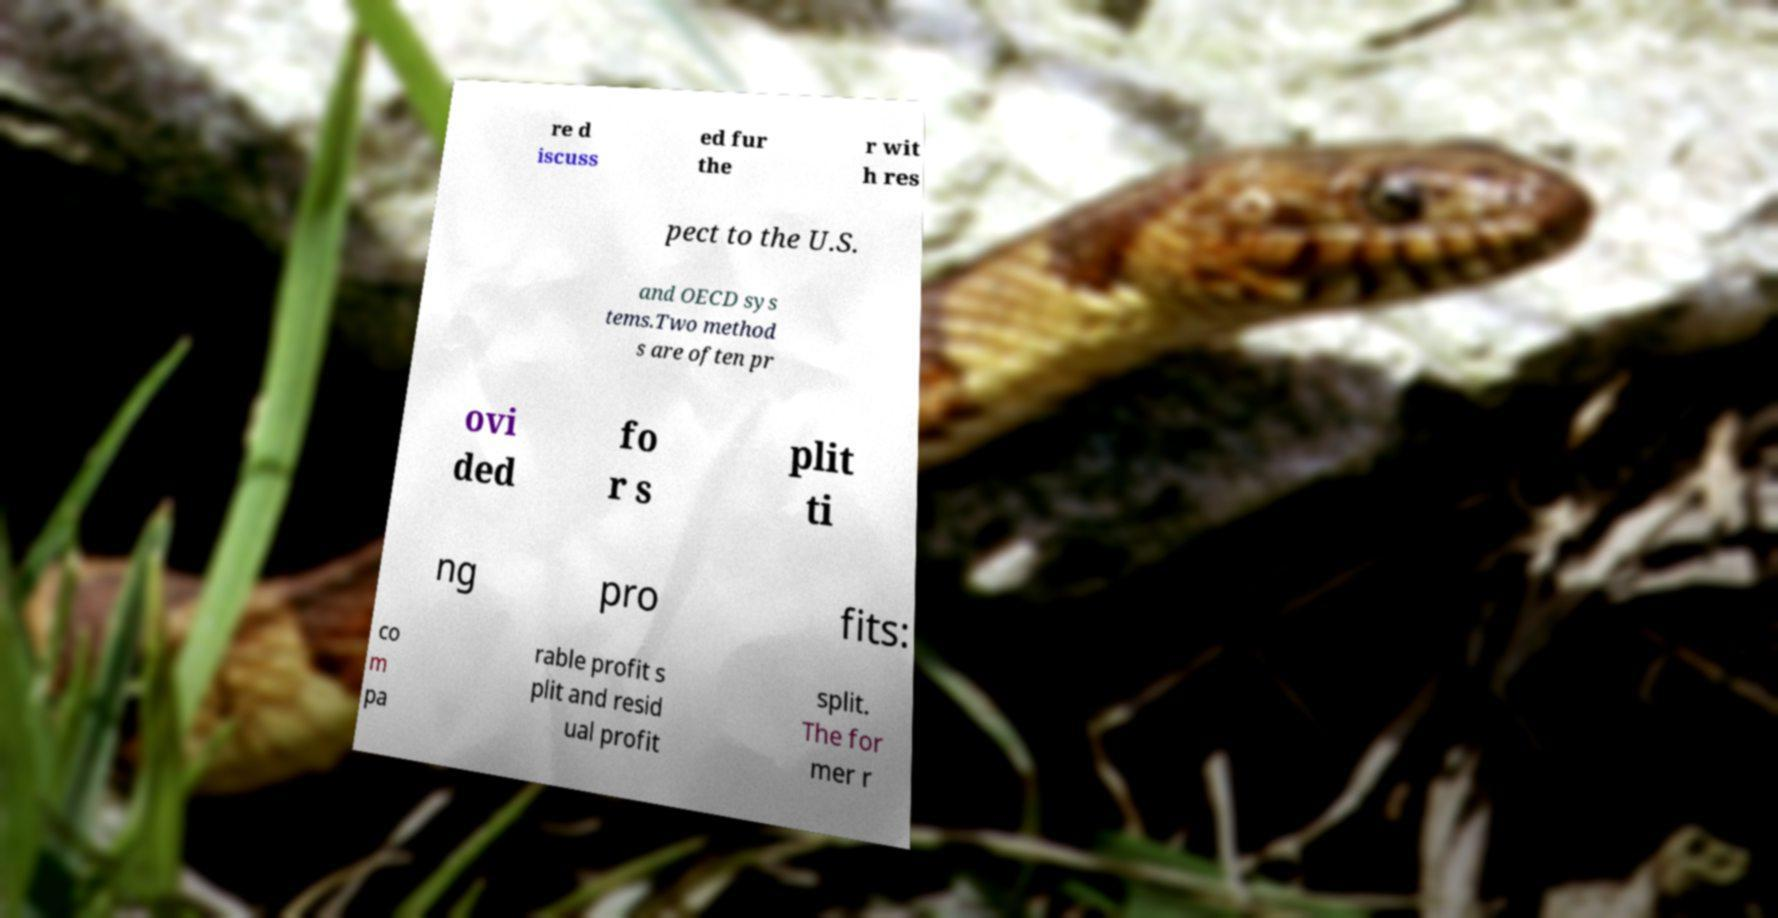Can you accurately transcribe the text from the provided image for me? re d iscuss ed fur the r wit h res pect to the U.S. and OECD sys tems.Two method s are often pr ovi ded fo r s plit ti ng pro fits: co m pa rable profit s plit and resid ual profit split. The for mer r 